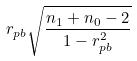<formula> <loc_0><loc_0><loc_500><loc_500>r _ { p b } \sqrt { \frac { n _ { 1 } + n _ { 0 } - 2 } { 1 - r _ { p b } ^ { 2 } } }</formula> 